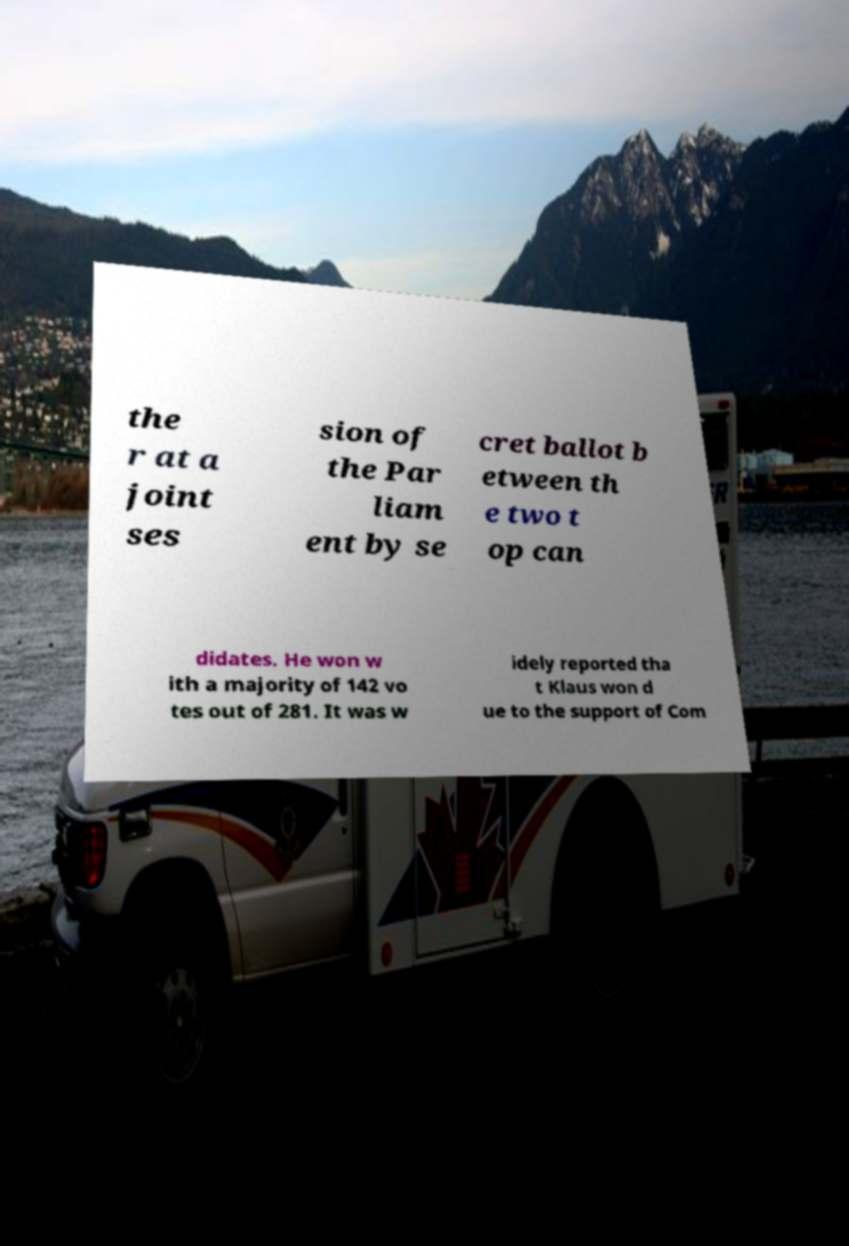For documentation purposes, I need the text within this image transcribed. Could you provide that? the r at a joint ses sion of the Par liam ent by se cret ballot b etween th e two t op can didates. He won w ith a majority of 142 vo tes out of 281. It was w idely reported tha t Klaus won d ue to the support of Com 